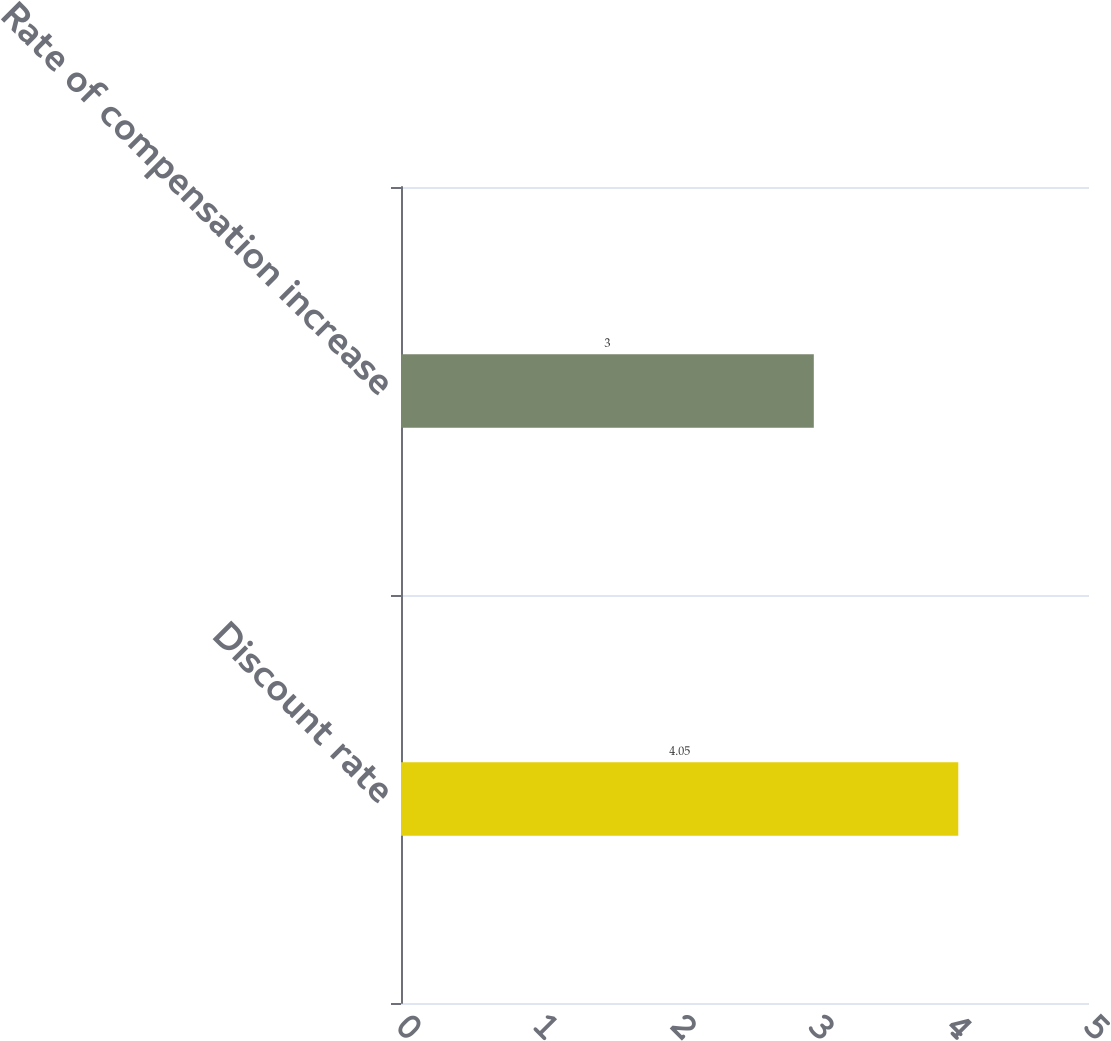<chart> <loc_0><loc_0><loc_500><loc_500><bar_chart><fcel>Discount rate<fcel>Rate of compensation increase<nl><fcel>4.05<fcel>3<nl></chart> 